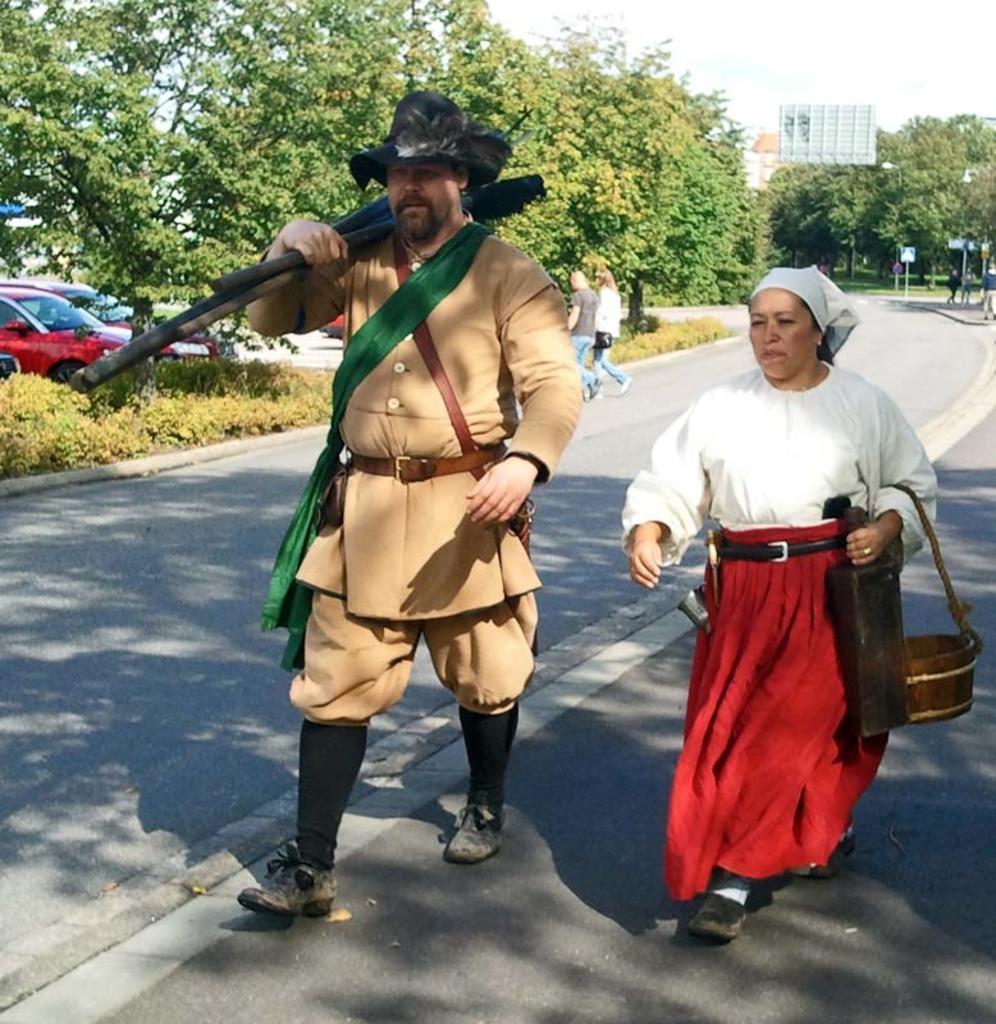Can you describe this image briefly? In the foreground, I can see four persons are walking on the road and are holding some objects in their hand. In the background, I can see vehicles on the road, fence, grass, trees, sign boards, group of people, buildings and the sky. This picture might be taken on the road. 